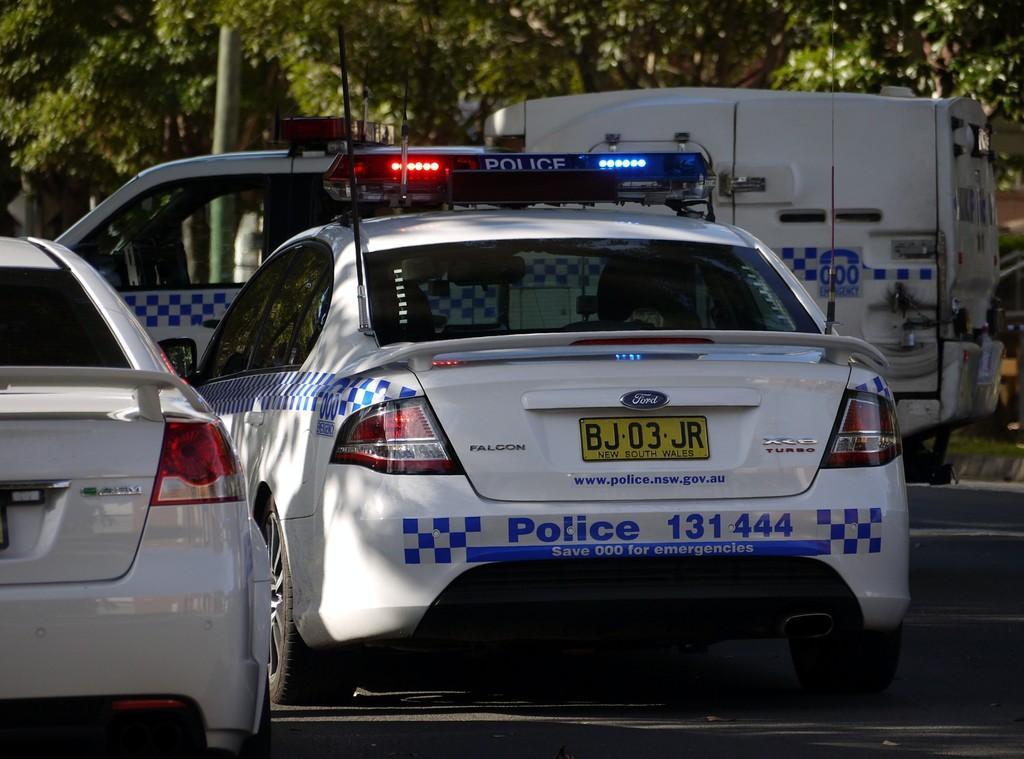Can you describe this image briefly? In this image we can see motor vehicles. In the background there are trees. 